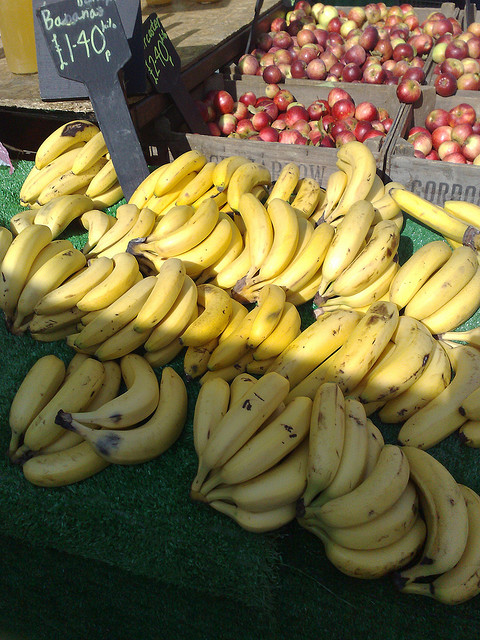How many bananas are in the photo? 11 